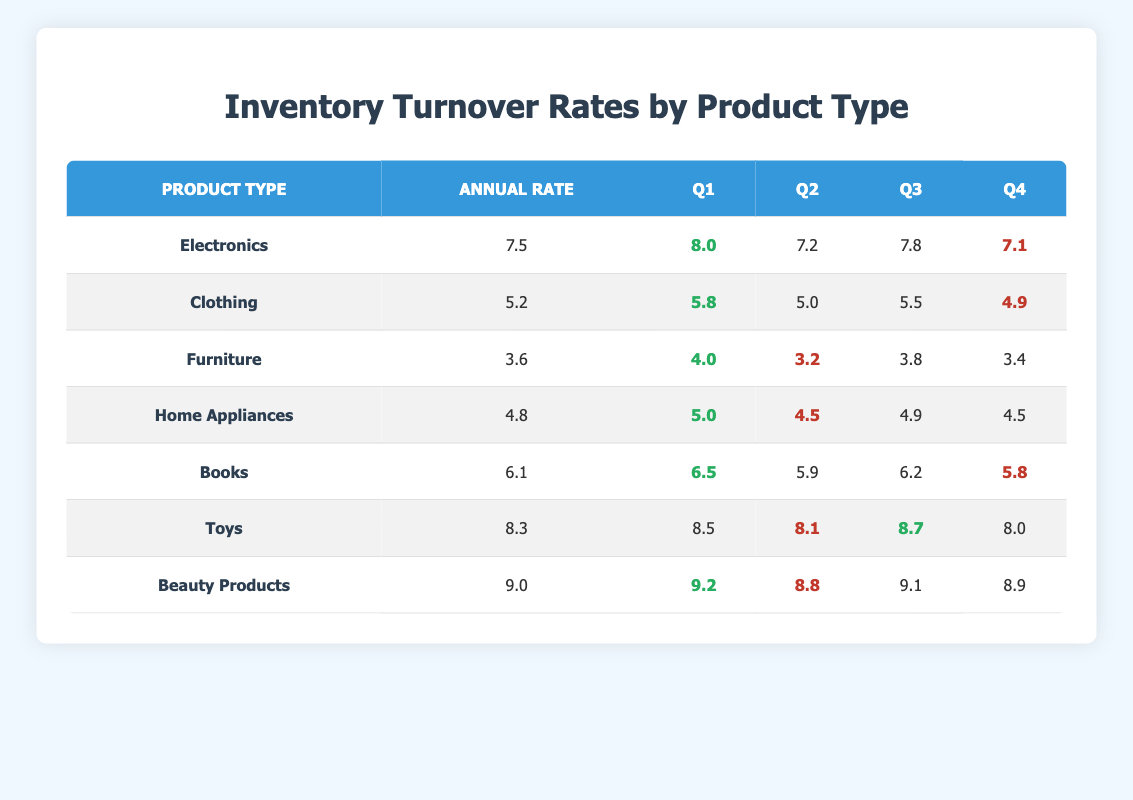What is the turnover rate for Electronics? The turnover rate is given directly in the table for Electronics, which is displayed in the column labeled "Annual Rate."
Answer: 7.5 Which product type has the lowest turnover rate in Quarter 2? Looking at the "Q2" column, the product types are: Electronics (7.2), Clothing (5.0), Furniture (3.2), Home Appliances (4.5), Books (5.9), Toys (8.1), and Beauty Products (8.8). The lowest value is 3.2 for Furniture.
Answer: Furniture What is the average turnover rate for Toys across all four quarters? The four quarter turnover rates for Toys are: 8.5, 8.1, 8.7, and 8.0. To find the average, sum these values: (8.5 + 8.1 + 8.7 + 8.0) = 33.3. There are 4 quarters, so the average is 33.3 / 4 = 8.325.
Answer: 8.325 Did the turnover rate for Home Appliances ever exceed 5.0 in any quarter? Checking the "Q1" value is 5.0, "Q2" is 4.5, "Q3" is 4.9, and "Q4" is 4.5. Since 5.0 is the maximum and occurs in "Q1," the answer is true; it did exceed 5.0.
Answer: Yes Which product type's turnover rate shows a consistent decline from Quarter 1 to Quarter 4? Observing the quarters for each product type: Clothing (5.8, 5.0, 5.5, 4.9) shows a decline, and Furniture (4.0, 3.2, 3.8, 3.4) also declines. Comparing these, Clothing does not show consistent decline, but Furniture does.
Answer: Furniture What is the difference between the highest and lowest turnover rates in Quarter 3? The highest turnover rate in Quarter 3 is for Toys at 8.7, and the lowest is for Furniture at 3.8. To find the difference, subtract the lowest from the highest: 8.7 - 3.8 = 4.9.
Answer: 4.9 Is the turnover rate for Beauty Products higher than that for Clothing in Quarter 4? The turnover rate for Beauty Products in Quarter 4 is 8.9, and for Clothing, it is 4.9. Since 8.9 is greater than 4.9, the answer is yes.
Answer: Yes 